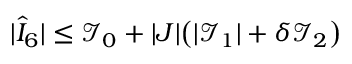Convert formula to latex. <formula><loc_0><loc_0><loc_500><loc_500>| \hat { I } _ { 6 } | \leq \mathcal { I } _ { 0 } + | J | \left ( | \mathcal { I } _ { 1 } | + \delta \mathcal { I } _ { 2 } \right )</formula> 